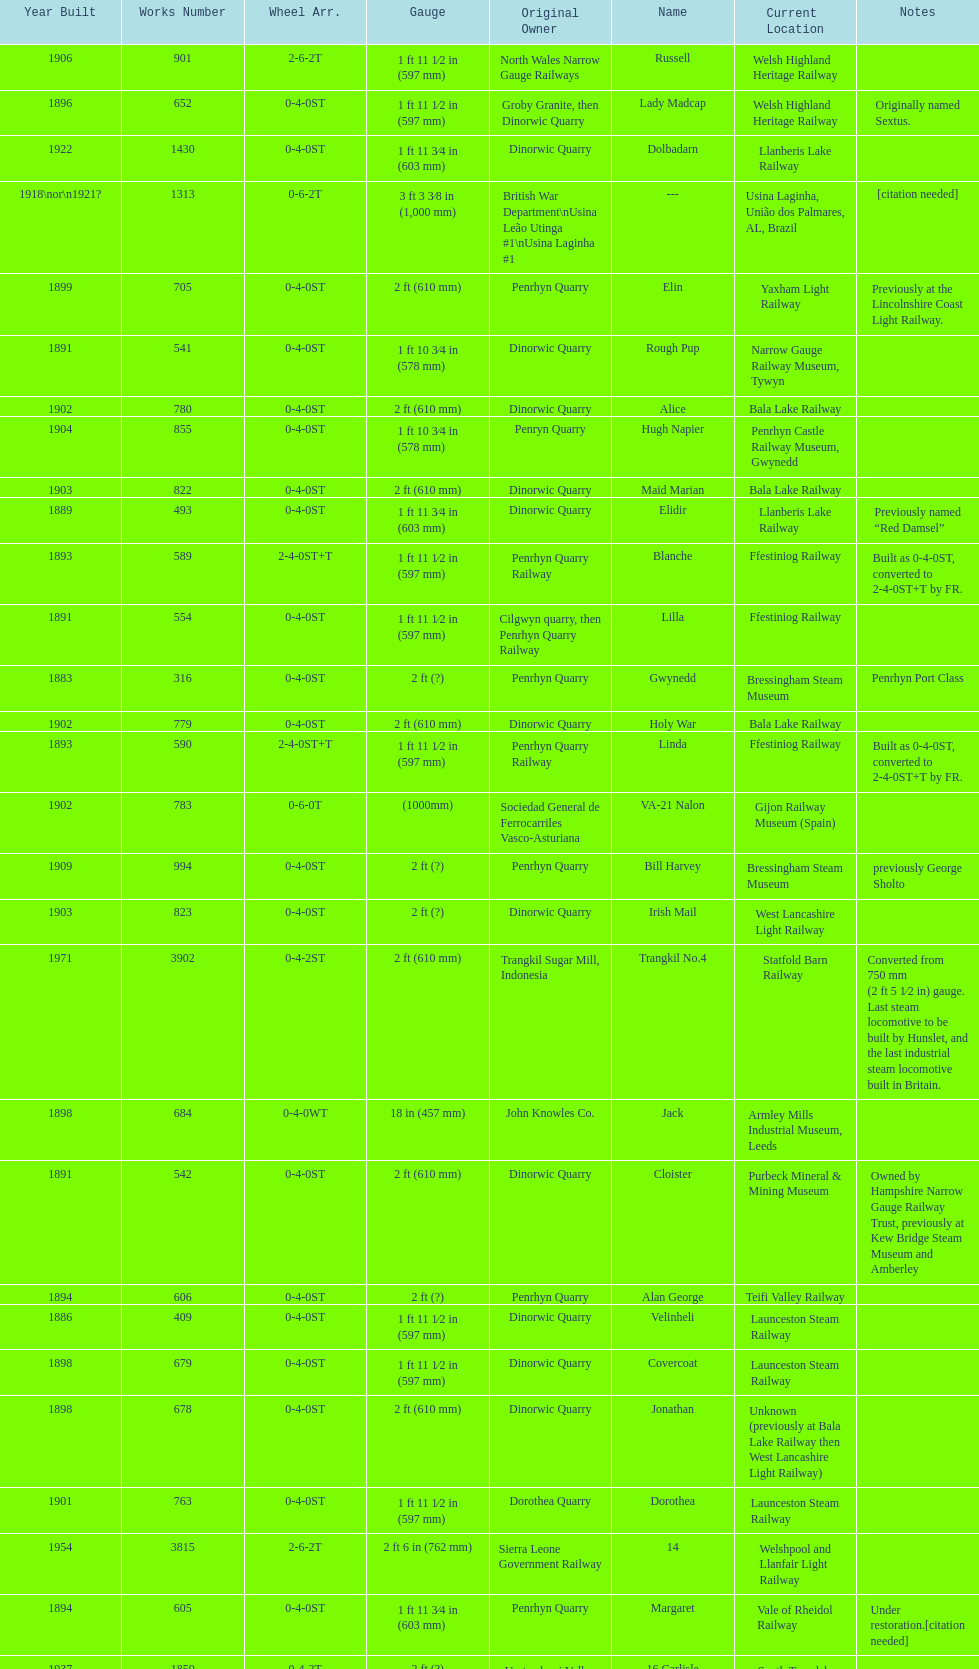What is the total number of preserved hunslet narrow gauge locomotives currently located in ffestiniog railway 554. 